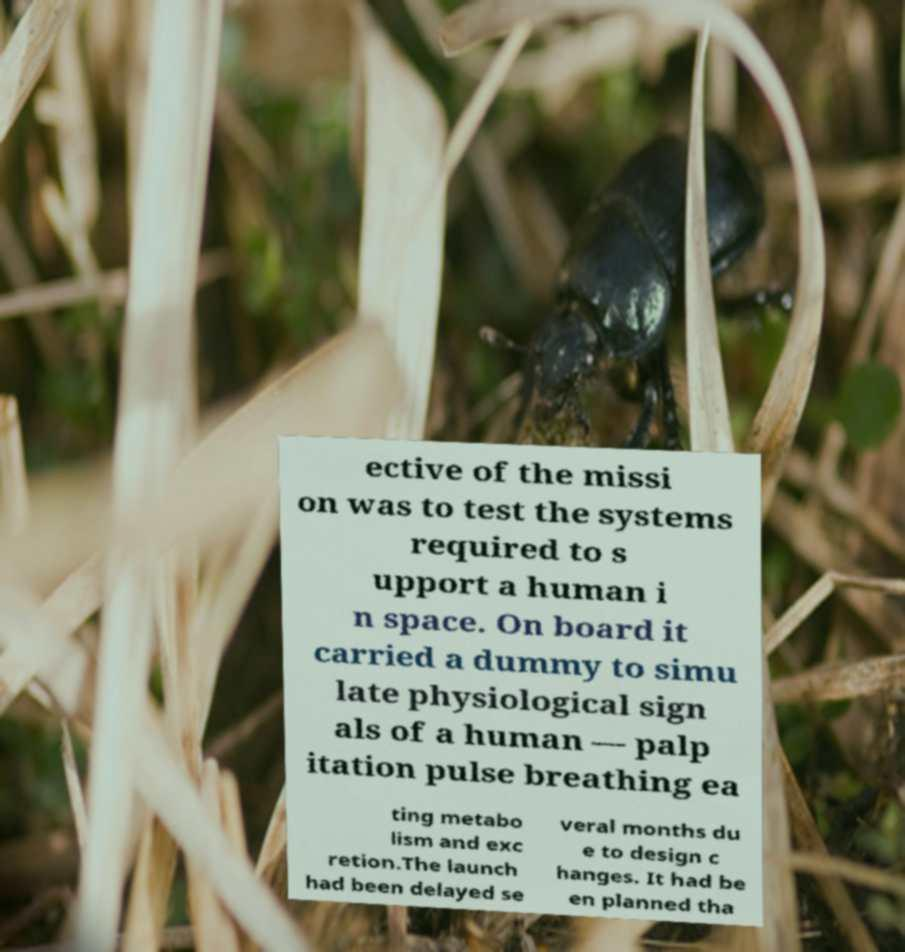Please read and relay the text visible in this image. What does it say? ective of the missi on was to test the systems required to s upport a human i n space. On board it carried a dummy to simu late physiological sign als of a human — palp itation pulse breathing ea ting metabo lism and exc retion.The launch had been delayed se veral months du e to design c hanges. It had be en planned tha 